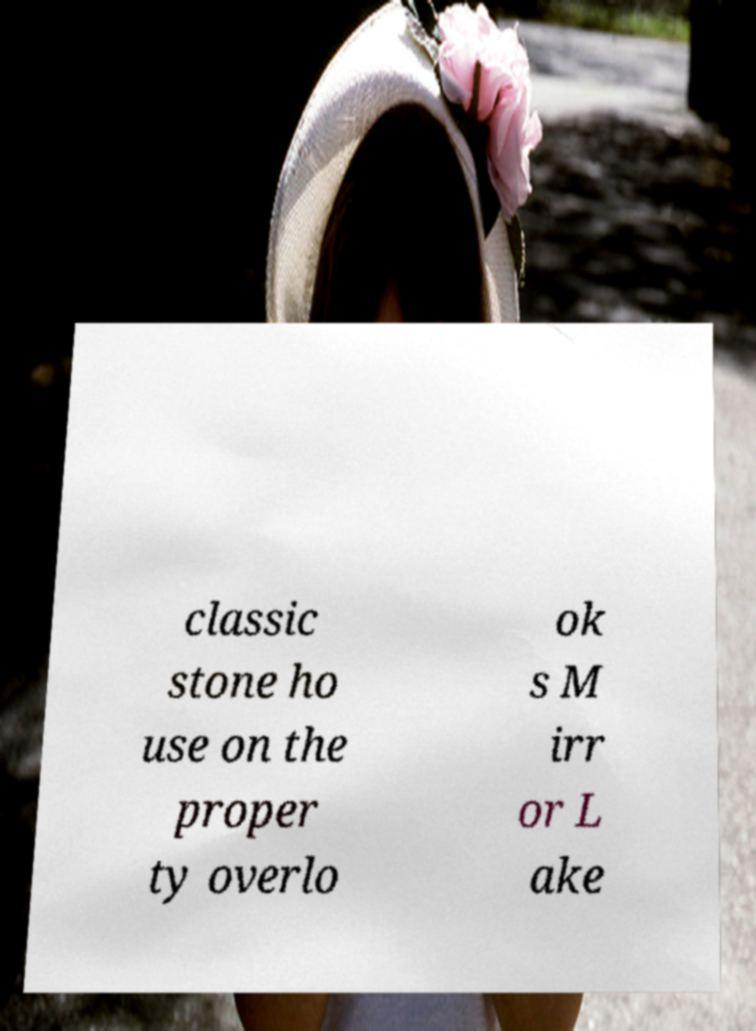Can you accurately transcribe the text from the provided image for me? classic stone ho use on the proper ty overlo ok s M irr or L ake 